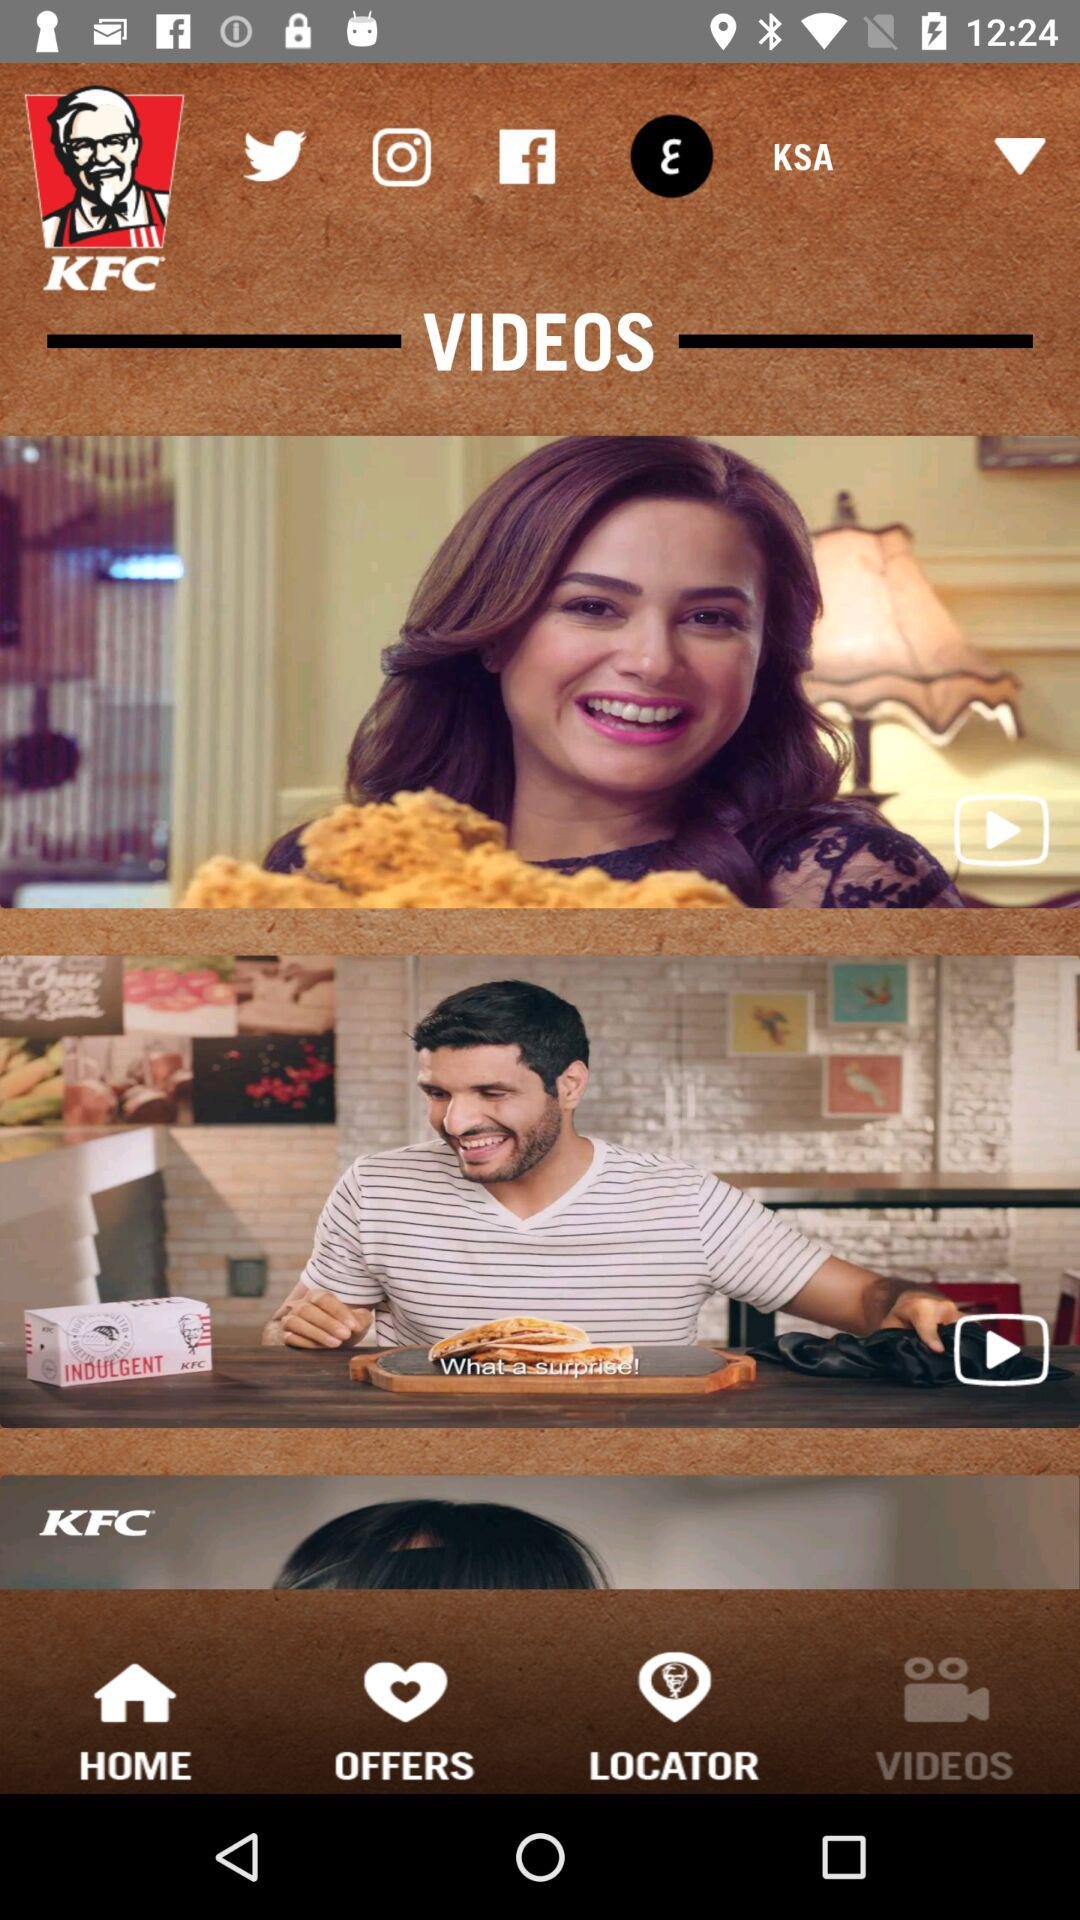What is the name of the application? The name of the application is "KFC". 